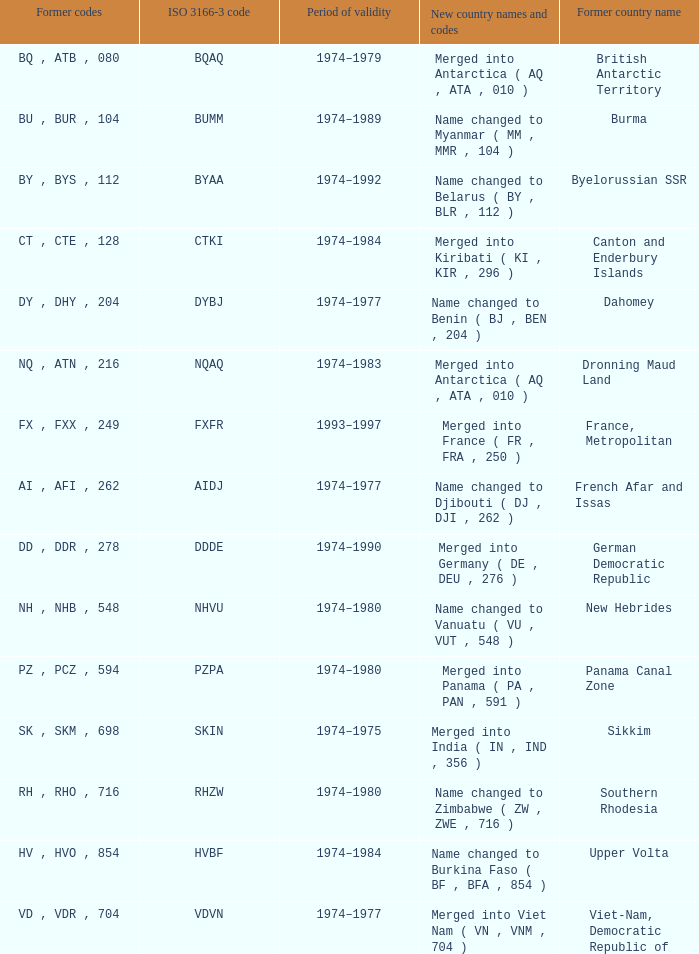What were the previous codes that were combined to form panama (pa, pan, 591)? PZ , PCZ , 594. 